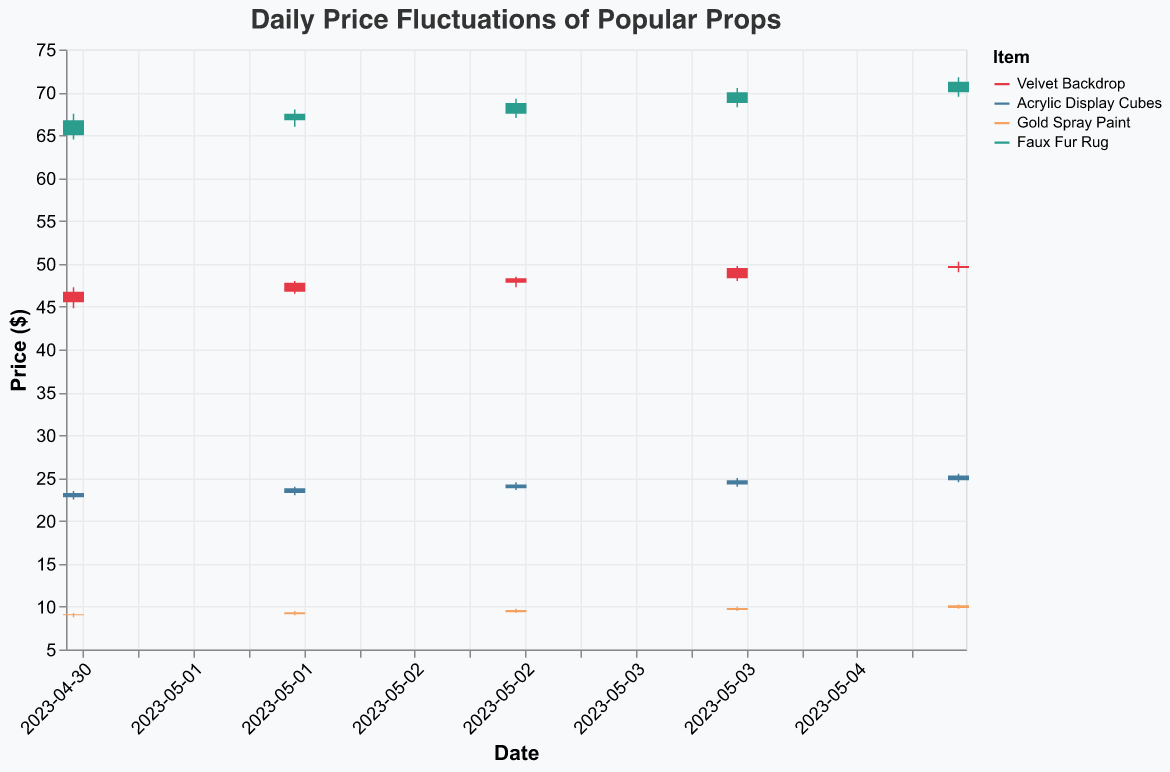What's the highest price reached for the Velvet Backdrop in the given data? To find the highest price for the Velvet Backdrop, look at the "High" values for all dates. The highest value is 50.25 on 2023-05-05.
Answer: 50.25 Which item had the most stable prices over the recorded period? To determine the most stable prices, compare the range (High - Low) for each item across multiple dates. The item with the smallest total range is Gold Spray Paint, with fluctuations from 8.75 to 10.25.
Answer: Gold Spray Paint On which date did the Faux Fur Rug have the lowest closing price, and what was it? To find the lowest closing price for the Faux Fur Rug, look at the "Close" values for all dates. The lowest closing price was 66.75 on 2023-05-01.
Answer: 2023-05-01, 66.75 By how much did the price of Acrylic Display Cubes increase from the opening on 2023-05-01 to the closing on 2023-05-05? Calculate the difference between the closing price on 2023-05-05 and the opening price on 2023-05-01. The closing price on 2023-05-05 is 25.30, and the opening price on 2023-05-01 is 22.75. The increase is 25.30 - 22.75 = 2.55.
Answer: 2.55 What is the overall trend in the price of Gold Spray Paint over the five days? Looking at the opening and closing prices over the five days, observe that the prices generally increased from opening 8.99 on 2023-05-01 to closing 10.15 on 2023-05-05. The trend is an upward movement.
Answer: Upward Which item had the largest price increase in a single day, and how much was it? Compare the day-to-day differences between the open and close prices for all items. The Velvet Backdrop had the largest daily increase on 2023-05-02, moving from 46.75 to 47.80, an increase of 1.05.
Answer: Velvet Backdrop, 1.05 Did the Velvet Backdrop's price ever close below its opening price on any given day? Compare the closing and opening prices for the Velvet Backdrop across the dates. On all recorded dates, the closing price was always higher than the opening price.
Answer: No What is the average closing price of the Faux Fur Rug over the entire period? To find the average closing price, sum all closing prices for the Faux Fur Rug and divide by the number of days. This is (66.75 + 67.50 + 68.75 + 70.00 + 71.25) / 5 = 68.85.
Answer: 68.85 Which date saw the highest price fluctuation for any item, and what was the amount? The highest fluctuation is the difference between the "High" and "Low" for each item on each date. On 2023-05-01, Faux Fur Rug had the highest fluctuation: 67.50 - 64.50 = 3.00.
Answer: 2023-05-01, 3.00 